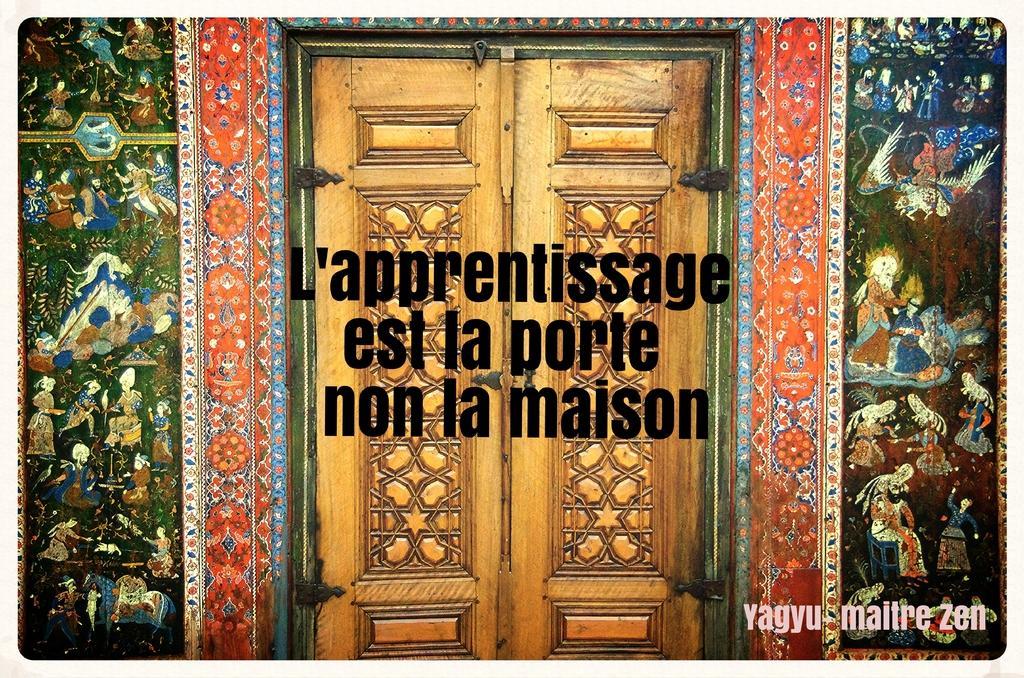In one or two sentences, can you explain what this image depicts? In the image there is a poster. On the poster there are walls with painting and also there is a door. In the middle of the image there is something written on it. 